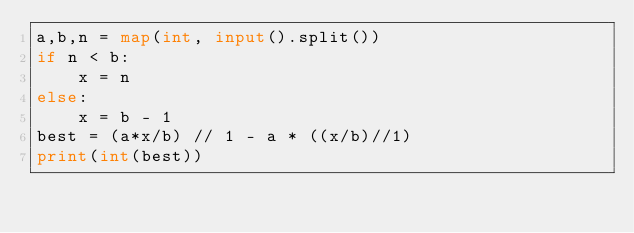<code> <loc_0><loc_0><loc_500><loc_500><_Python_>a,b,n = map(int, input().split())
if n < b:
    x = n
else:
    x = b - 1
best = (a*x/b) // 1 - a * ((x/b)//1)
print(int(best))</code> 